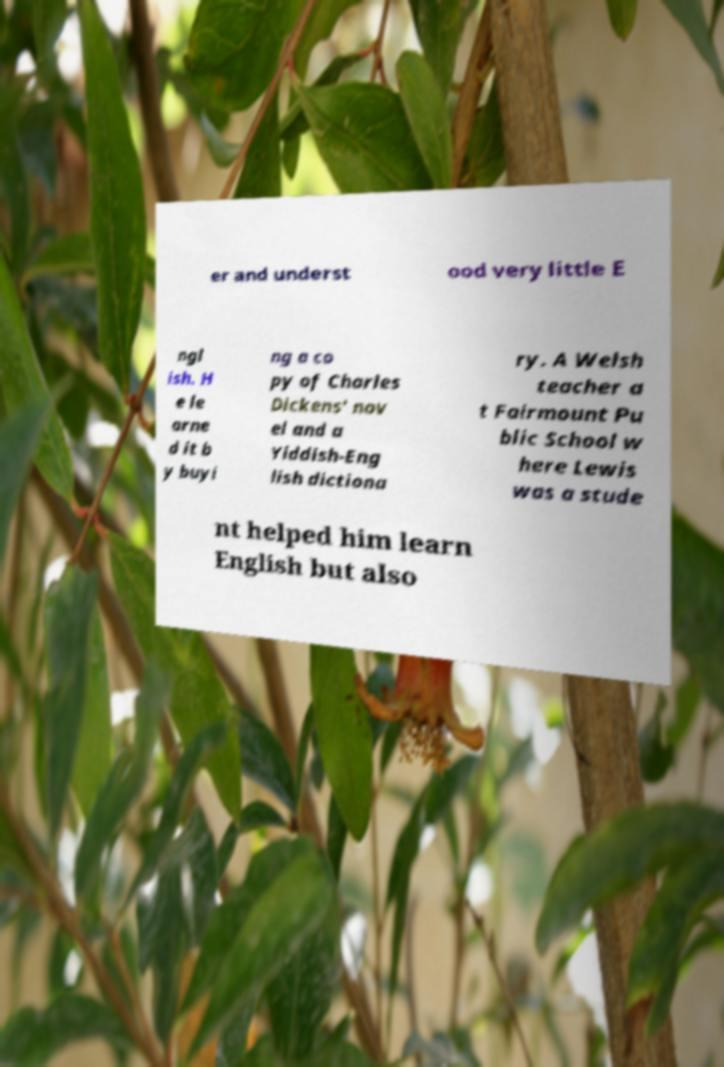Please read and relay the text visible in this image. What does it say? er and underst ood very little E ngl ish. H e le arne d it b y buyi ng a co py of Charles Dickens' nov el and a Yiddish-Eng lish dictiona ry. A Welsh teacher a t Fairmount Pu blic School w here Lewis was a stude nt helped him learn English but also 